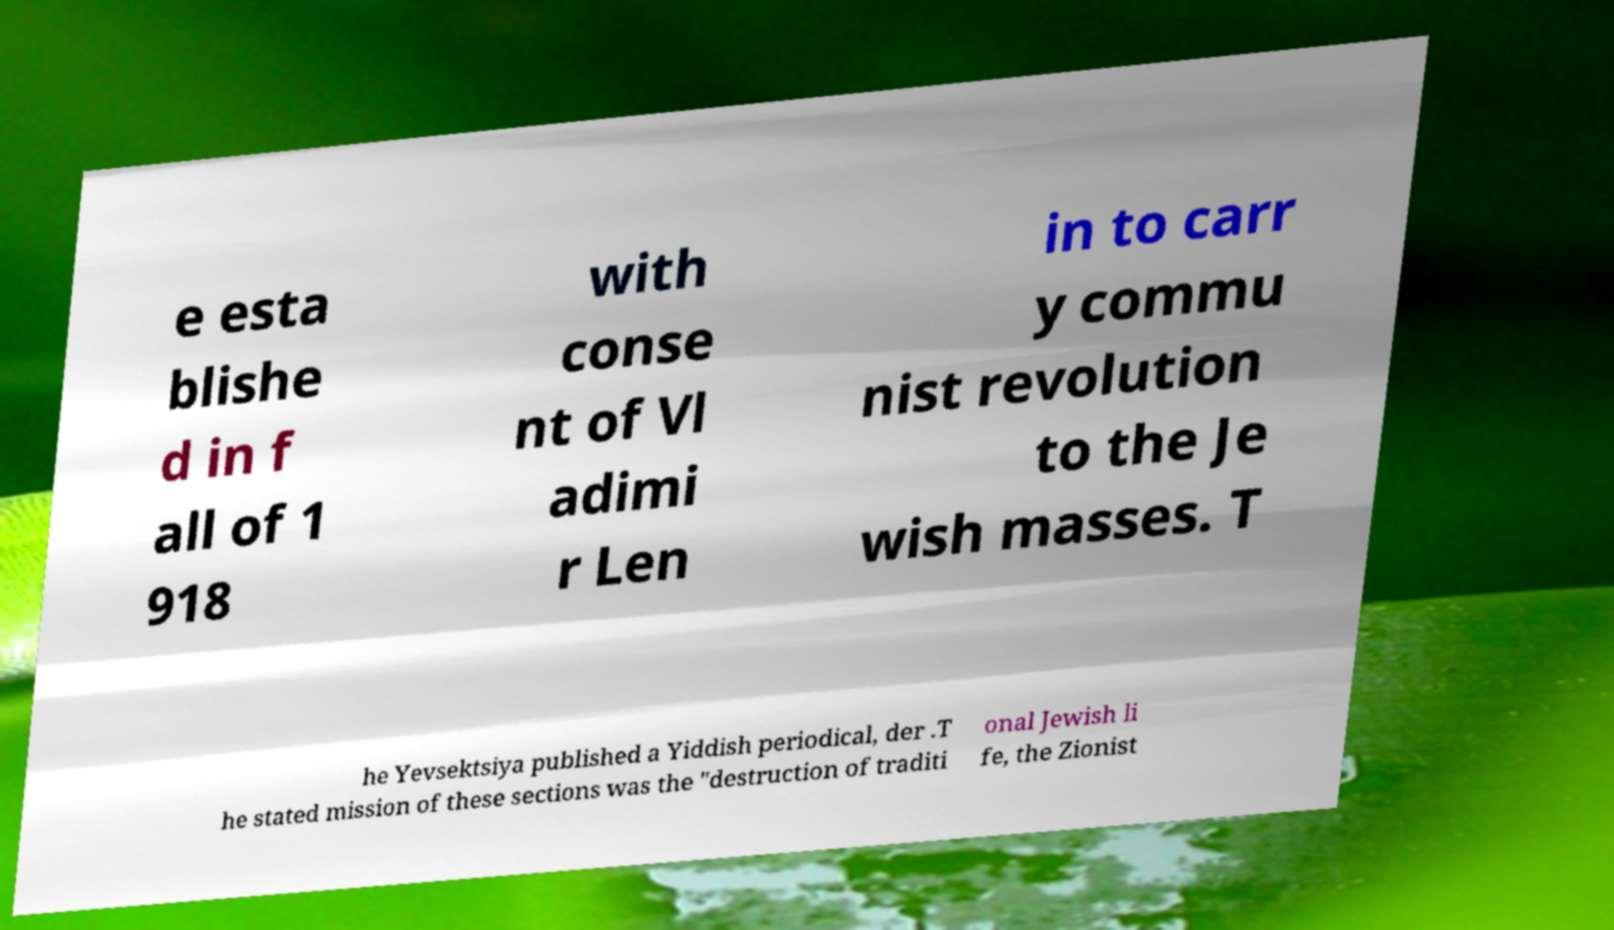Can you read and provide the text displayed in the image?This photo seems to have some interesting text. Can you extract and type it out for me? e esta blishe d in f all of 1 918 with conse nt of Vl adimi r Len in to carr y commu nist revolution to the Je wish masses. T he Yevsektsiya published a Yiddish periodical, der .T he stated mission of these sections was the "destruction of traditi onal Jewish li fe, the Zionist 